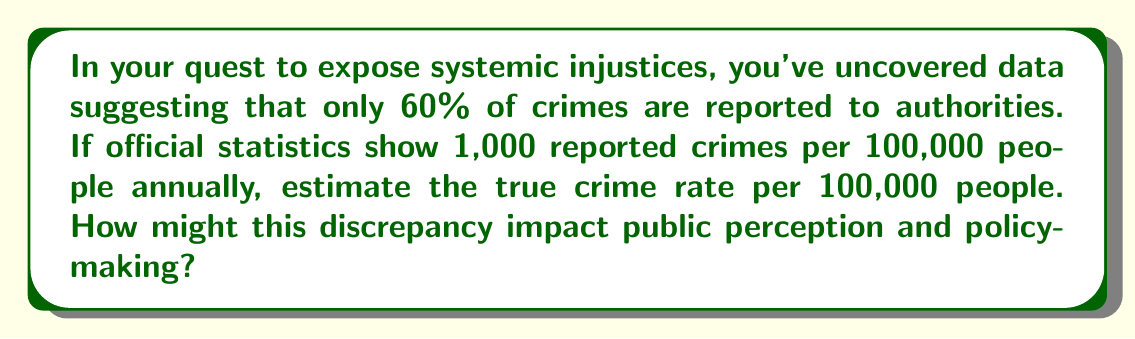Solve this math problem. To solve this inverse problem and estimate the true crime rate, we need to work backwards from the reported statistics. Let's approach this step-by-step:

1) Let $x$ be the true number of crimes per 100,000 people.

2) We know that only 60% of crimes are reported. This means:
   $0.60x = 1,000$

3) To find $x$, we divide both sides by 0.60:
   $x = \frac{1,000}{0.60}$

4) Simplifying:
   $x = \frac{1,000}{0.60} = \frac{10,000}{6} \approx 1,666.67$

5) Therefore, the estimated true crime rate is approximately 1,667 per 100,000 people.

This discrepancy between reported and actual crime rates can significantly impact public perception and policy-making. The underreporting of crimes may lead to:

a) Underestimation of the scale of criminal activity
b) Misallocation of law enforcement resources
c) Inadequate support for victims and affected communities
d) Policies that fail to address the full extent of criminal activity

As an activist poet, this information could be powerful in highlighting the need for more comprehensive crime reporting systems and policies that address unreported crimes.
Answer: 1,667 crimes per 100,000 people 